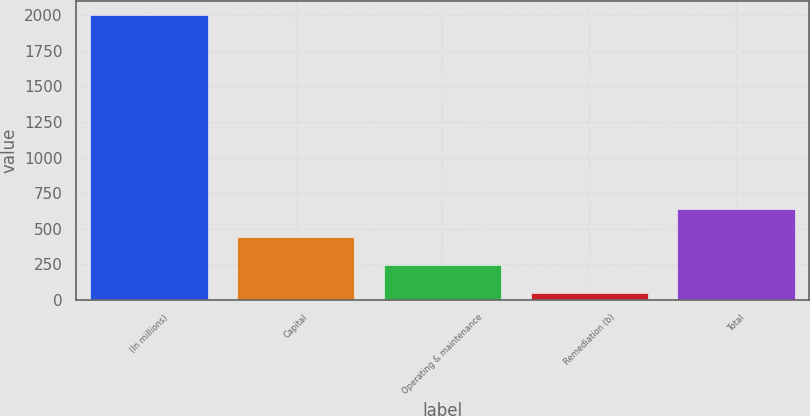<chart> <loc_0><loc_0><loc_500><loc_500><bar_chart><fcel>(In millions)<fcel>Capital<fcel>Operating & maintenance<fcel>Remediation (b)<fcel>Total<nl><fcel>2003<fcel>438.9<fcel>243<fcel>44<fcel>634.8<nl></chart> 